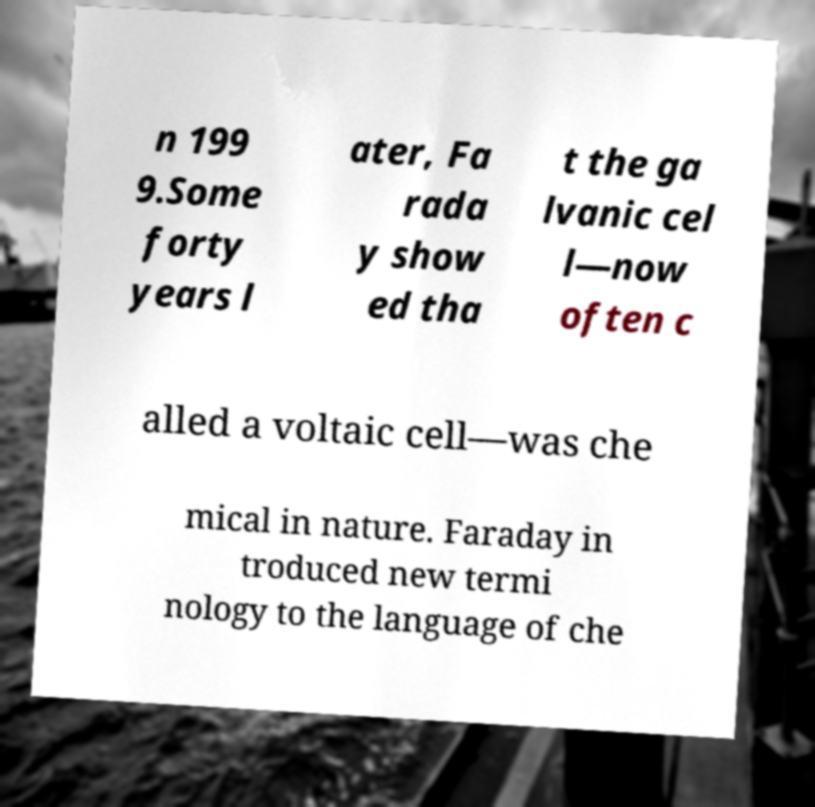Please read and relay the text visible in this image. What does it say? n 199 9.Some forty years l ater, Fa rada y show ed tha t the ga lvanic cel l—now often c alled a voltaic cell—was che mical in nature. Faraday in troduced new termi nology to the language of che 